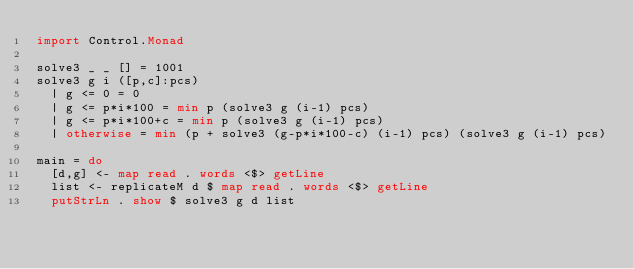<code> <loc_0><loc_0><loc_500><loc_500><_Haskell_>import Control.Monad

solve3 _ _ [] = 1001
solve3 g i ([p,c]:pcs)
  | g <= 0 = 0
  | g <= p*i*100 = min p (solve3 g (i-1) pcs)
  | g <= p*i*100+c = min p (solve3 g (i-1) pcs)
  | otherwise = min (p + solve3 (g-p*i*100-c) (i-1) pcs) (solve3 g (i-1) pcs)

main = do
  [d,g] <- map read . words <$> getLine
  list <- replicateM d $ map read . words <$> getLine
  putStrLn . show $ solve3 g d list
</code> 